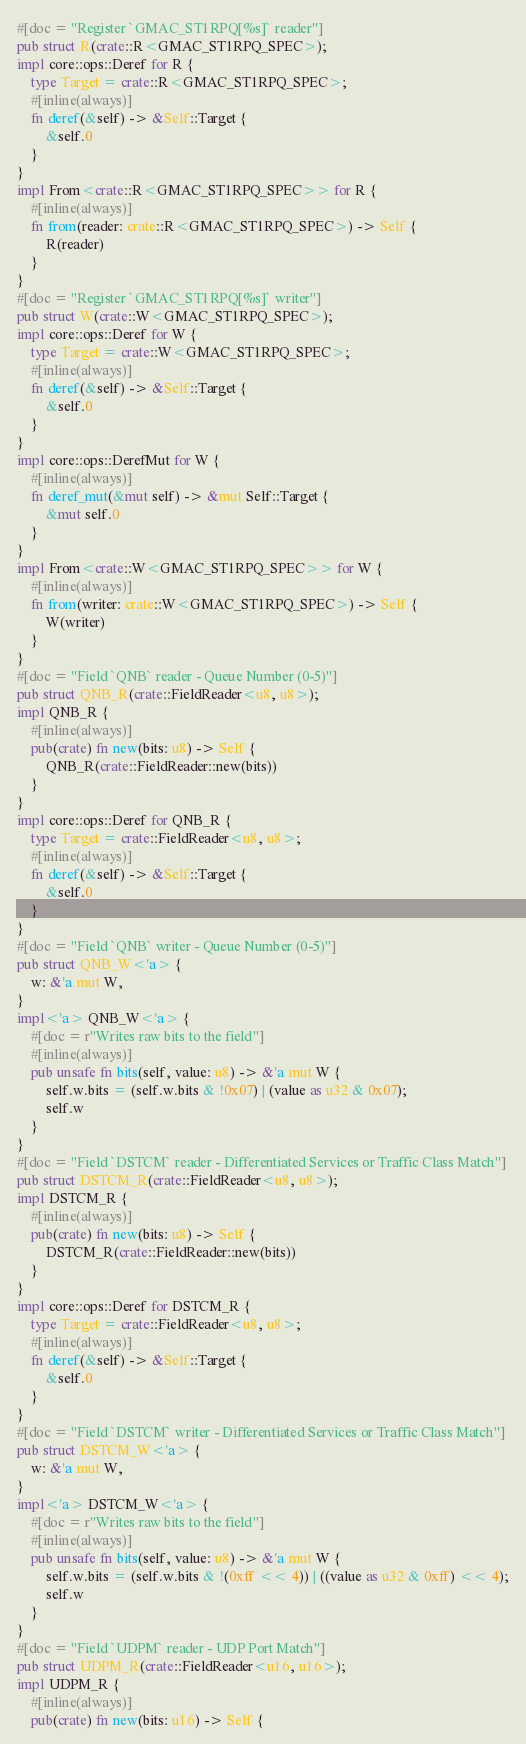Convert code to text. <code><loc_0><loc_0><loc_500><loc_500><_Rust_>#[doc = "Register `GMAC_ST1RPQ[%s]` reader"]
pub struct R(crate::R<GMAC_ST1RPQ_SPEC>);
impl core::ops::Deref for R {
    type Target = crate::R<GMAC_ST1RPQ_SPEC>;
    #[inline(always)]
    fn deref(&self) -> &Self::Target {
        &self.0
    }
}
impl From<crate::R<GMAC_ST1RPQ_SPEC>> for R {
    #[inline(always)]
    fn from(reader: crate::R<GMAC_ST1RPQ_SPEC>) -> Self {
        R(reader)
    }
}
#[doc = "Register `GMAC_ST1RPQ[%s]` writer"]
pub struct W(crate::W<GMAC_ST1RPQ_SPEC>);
impl core::ops::Deref for W {
    type Target = crate::W<GMAC_ST1RPQ_SPEC>;
    #[inline(always)]
    fn deref(&self) -> &Self::Target {
        &self.0
    }
}
impl core::ops::DerefMut for W {
    #[inline(always)]
    fn deref_mut(&mut self) -> &mut Self::Target {
        &mut self.0
    }
}
impl From<crate::W<GMAC_ST1RPQ_SPEC>> for W {
    #[inline(always)]
    fn from(writer: crate::W<GMAC_ST1RPQ_SPEC>) -> Self {
        W(writer)
    }
}
#[doc = "Field `QNB` reader - Queue Number (0-5)"]
pub struct QNB_R(crate::FieldReader<u8, u8>);
impl QNB_R {
    #[inline(always)]
    pub(crate) fn new(bits: u8) -> Self {
        QNB_R(crate::FieldReader::new(bits))
    }
}
impl core::ops::Deref for QNB_R {
    type Target = crate::FieldReader<u8, u8>;
    #[inline(always)]
    fn deref(&self) -> &Self::Target {
        &self.0
    }
}
#[doc = "Field `QNB` writer - Queue Number (0-5)"]
pub struct QNB_W<'a> {
    w: &'a mut W,
}
impl<'a> QNB_W<'a> {
    #[doc = r"Writes raw bits to the field"]
    #[inline(always)]
    pub unsafe fn bits(self, value: u8) -> &'a mut W {
        self.w.bits = (self.w.bits & !0x07) | (value as u32 & 0x07);
        self.w
    }
}
#[doc = "Field `DSTCM` reader - Differentiated Services or Traffic Class Match"]
pub struct DSTCM_R(crate::FieldReader<u8, u8>);
impl DSTCM_R {
    #[inline(always)]
    pub(crate) fn new(bits: u8) -> Self {
        DSTCM_R(crate::FieldReader::new(bits))
    }
}
impl core::ops::Deref for DSTCM_R {
    type Target = crate::FieldReader<u8, u8>;
    #[inline(always)]
    fn deref(&self) -> &Self::Target {
        &self.0
    }
}
#[doc = "Field `DSTCM` writer - Differentiated Services or Traffic Class Match"]
pub struct DSTCM_W<'a> {
    w: &'a mut W,
}
impl<'a> DSTCM_W<'a> {
    #[doc = r"Writes raw bits to the field"]
    #[inline(always)]
    pub unsafe fn bits(self, value: u8) -> &'a mut W {
        self.w.bits = (self.w.bits & !(0xff << 4)) | ((value as u32 & 0xff) << 4);
        self.w
    }
}
#[doc = "Field `UDPM` reader - UDP Port Match"]
pub struct UDPM_R(crate::FieldReader<u16, u16>);
impl UDPM_R {
    #[inline(always)]
    pub(crate) fn new(bits: u16) -> Self {</code> 